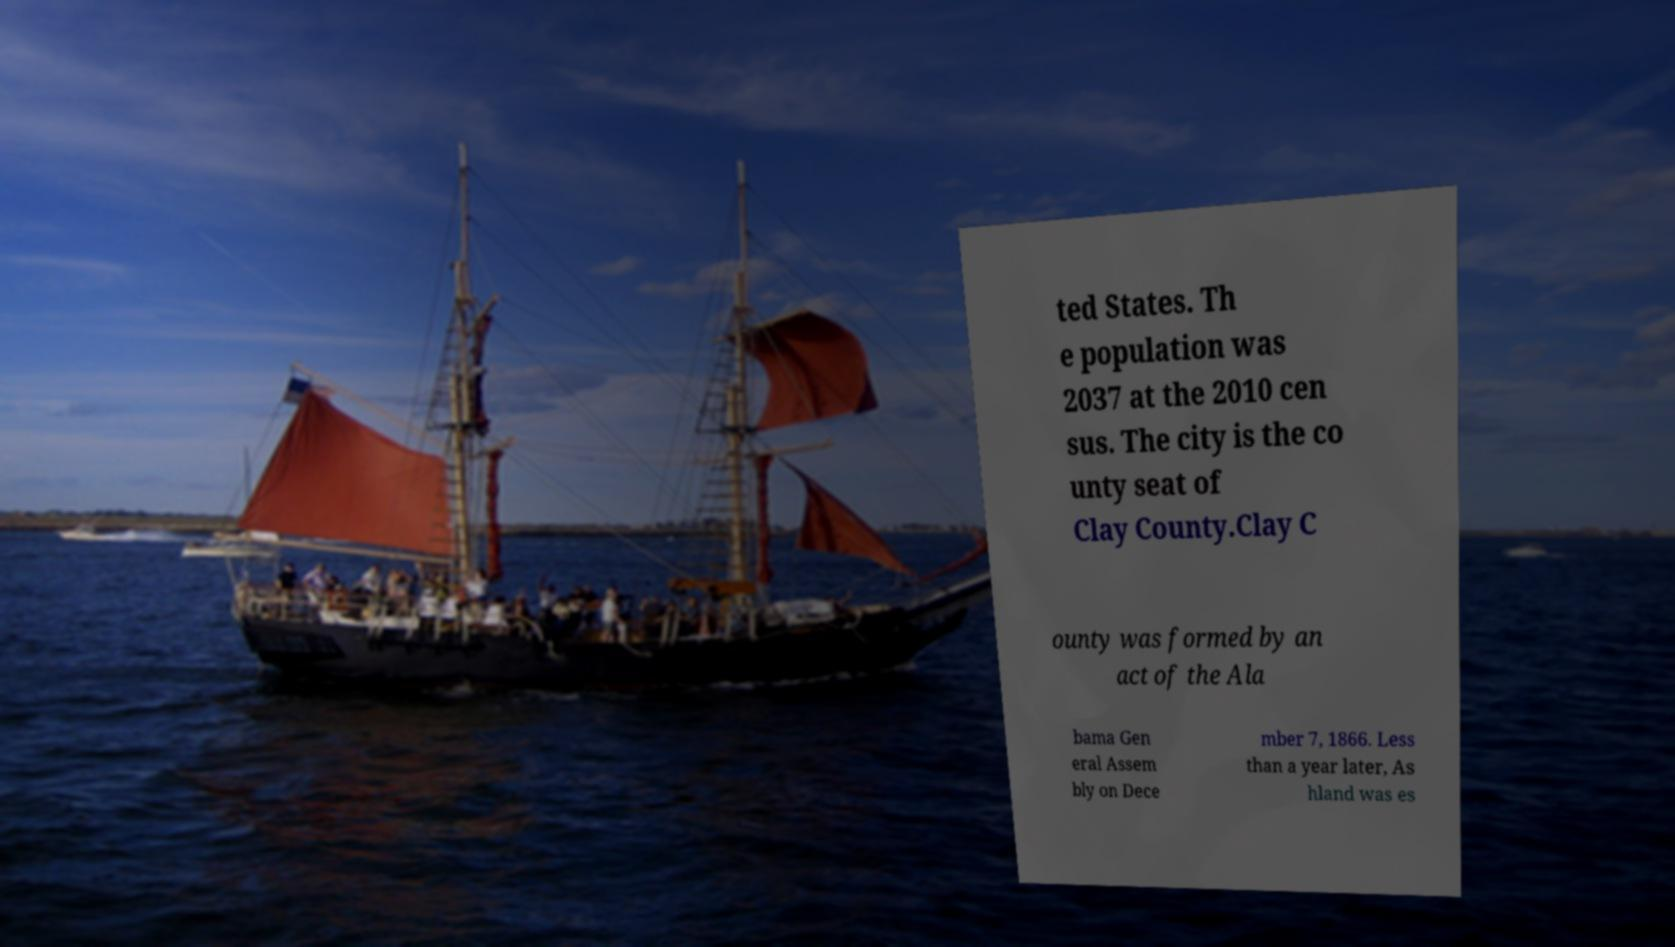I need the written content from this picture converted into text. Can you do that? ted States. Th e population was 2037 at the 2010 cen sus. The city is the co unty seat of Clay County.Clay C ounty was formed by an act of the Ala bama Gen eral Assem bly on Dece mber 7, 1866. Less than a year later, As hland was es 